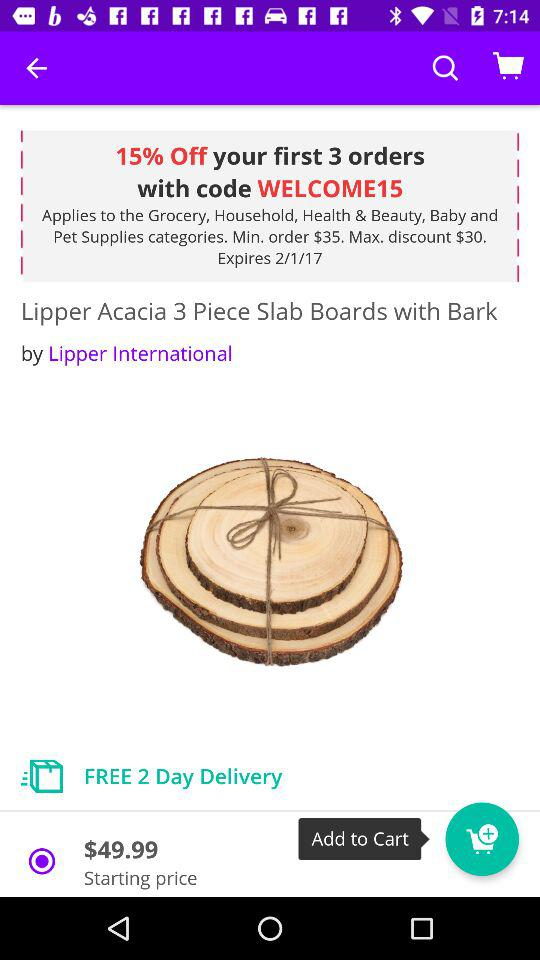What is the date when the offers will expire? It will expire on February 1, 2017. 